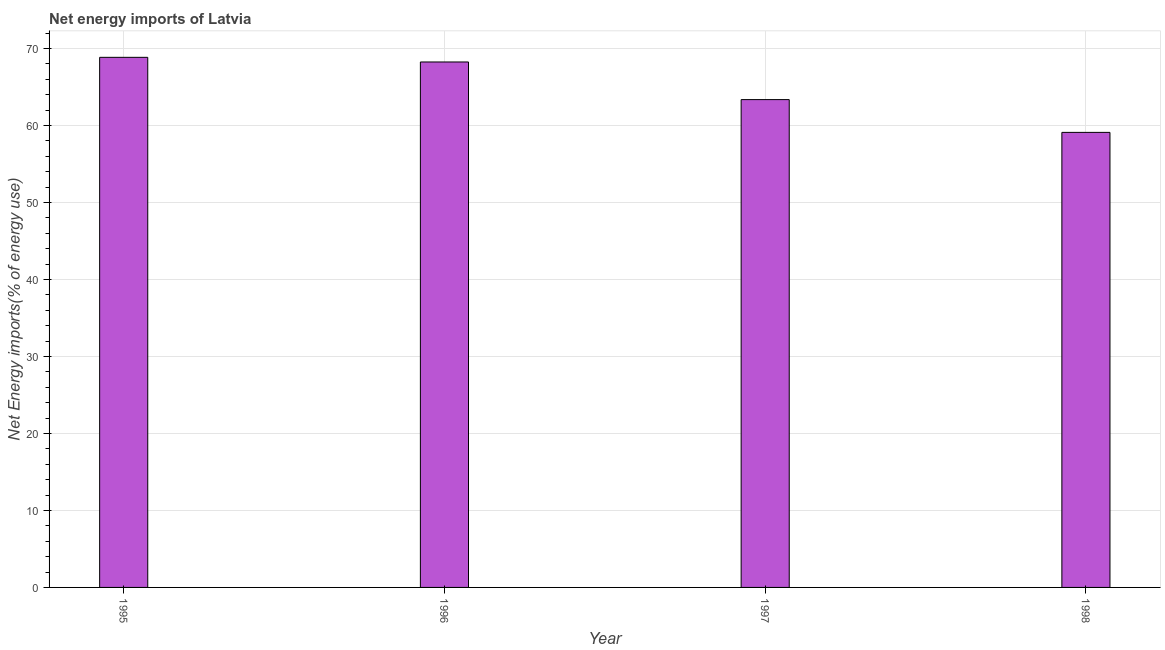Does the graph contain any zero values?
Give a very brief answer. No. What is the title of the graph?
Offer a terse response. Net energy imports of Latvia. What is the label or title of the Y-axis?
Provide a succinct answer. Net Energy imports(% of energy use). What is the energy imports in 1996?
Offer a very short reply. 68.25. Across all years, what is the maximum energy imports?
Your response must be concise. 68.85. Across all years, what is the minimum energy imports?
Your response must be concise. 59.1. In which year was the energy imports minimum?
Offer a very short reply. 1998. What is the sum of the energy imports?
Ensure brevity in your answer.  259.55. What is the difference between the energy imports in 1995 and 1998?
Provide a succinct answer. 9.75. What is the average energy imports per year?
Provide a succinct answer. 64.89. What is the median energy imports?
Offer a very short reply. 65.8. Is the energy imports in 1997 less than that in 1998?
Your answer should be very brief. No. Is the difference between the energy imports in 1996 and 1998 greater than the difference between any two years?
Offer a very short reply. No. What is the difference between the highest and the second highest energy imports?
Offer a very short reply. 0.6. Is the sum of the energy imports in 1996 and 1997 greater than the maximum energy imports across all years?
Provide a succinct answer. Yes. What is the difference between the highest and the lowest energy imports?
Give a very brief answer. 9.75. In how many years, is the energy imports greater than the average energy imports taken over all years?
Offer a very short reply. 2. Are all the bars in the graph horizontal?
Your answer should be very brief. No. What is the difference between two consecutive major ticks on the Y-axis?
Make the answer very short. 10. What is the Net Energy imports(% of energy use) in 1995?
Provide a short and direct response. 68.85. What is the Net Energy imports(% of energy use) of 1996?
Make the answer very short. 68.25. What is the Net Energy imports(% of energy use) in 1997?
Keep it short and to the point. 63.36. What is the Net Energy imports(% of energy use) of 1998?
Ensure brevity in your answer.  59.1. What is the difference between the Net Energy imports(% of energy use) in 1995 and 1996?
Your answer should be compact. 0.6. What is the difference between the Net Energy imports(% of energy use) in 1995 and 1997?
Give a very brief answer. 5.49. What is the difference between the Net Energy imports(% of energy use) in 1995 and 1998?
Give a very brief answer. 9.75. What is the difference between the Net Energy imports(% of energy use) in 1996 and 1997?
Your answer should be very brief. 4.89. What is the difference between the Net Energy imports(% of energy use) in 1996 and 1998?
Ensure brevity in your answer.  9.14. What is the difference between the Net Energy imports(% of energy use) in 1997 and 1998?
Your answer should be compact. 4.26. What is the ratio of the Net Energy imports(% of energy use) in 1995 to that in 1997?
Give a very brief answer. 1.09. What is the ratio of the Net Energy imports(% of energy use) in 1995 to that in 1998?
Your answer should be compact. 1.17. What is the ratio of the Net Energy imports(% of energy use) in 1996 to that in 1997?
Provide a succinct answer. 1.08. What is the ratio of the Net Energy imports(% of energy use) in 1996 to that in 1998?
Make the answer very short. 1.16. What is the ratio of the Net Energy imports(% of energy use) in 1997 to that in 1998?
Keep it short and to the point. 1.07. 